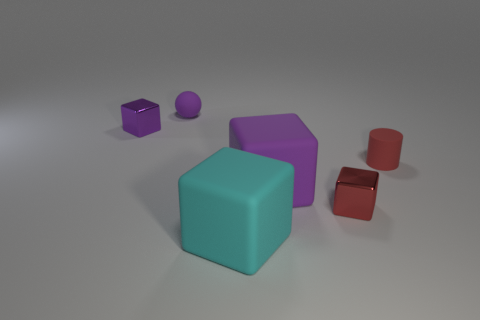There is a big cyan thing that is the same shape as the small red metal thing; what material is it?
Provide a short and direct response. Rubber. The small metallic block behind the purple block that is in front of the small metal cube left of the large cyan cube is what color?
Ensure brevity in your answer.  Purple. What is the shape of the matte thing that is the same color as the tiny matte sphere?
Offer a very short reply. Cube. There is a metallic cube behind the large purple matte thing; what is its size?
Give a very brief answer. Small. The purple rubber object that is the same size as the red metallic block is what shape?
Your answer should be very brief. Sphere. Is the material of the small thing that is on the left side of the ball the same as the small cube that is to the right of the large cyan block?
Your answer should be compact. Yes. The big thing in front of the large purple block to the right of the small purple metallic thing is made of what material?
Your answer should be very brief. Rubber. What is the size of the matte cube behind the large cube in front of the tiny red thing in front of the red rubber object?
Offer a very short reply. Large. Is the size of the red rubber object the same as the cyan cube?
Provide a succinct answer. No. There is a big cyan object that is to the left of the red matte cylinder; is its shape the same as the metallic thing that is in front of the small purple shiny block?
Give a very brief answer. Yes. 